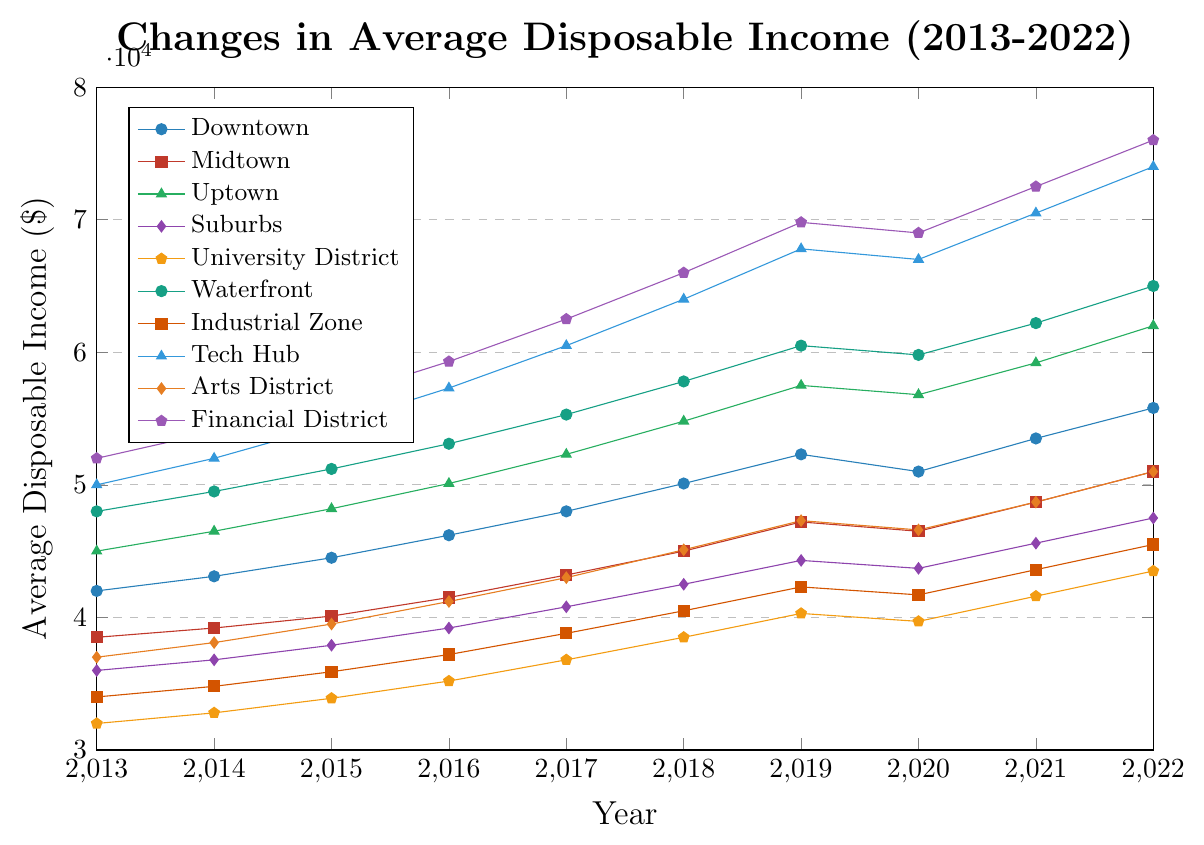What year did Downtown experience a decrease in average disposable income? Locate the data for Downtown and identify the year where the line dips. The average disposable income for Downtown decreases from 2019 to 2020, dipping from $52,300 to $51,000.
Answer: 2020 Which neighborhood had the highest disposable income in 2022? Locate the line for each neighborhood in the year 2022 and identify the highest value. The Financial District had the highest disposable income in 2022 with $76,000.
Answer: Financial District By how much did the disposable income in Tech Hub increase from 2013 to 2022? Identify the starting (2013) and ending (2022) values for Tech Hub and calculate the difference. The income increased from $50,000 in 2013 to $74,000 in 2022, resulting in an increase of $24,000.
Answer: $24,000 Which neighborhoods had disposable incomes greater than $50,000 in 2022? Review the 2022 disposable incomes for all neighborhoods and select those greater than $50,000. The neighborhoods are Downtown, Midtown, Uptown, Waterfront, Tech Hub, and Financial District.
Answer: Downtown, Midtown, Uptown, Waterfront, Tech Hub, Financial District Did the University District’s average disposable income ever exceed $40,000 before 2019? Check the disposable incomes for University District from 2013 to 2018. The income exceeds $40,000 in 2018 when it reaches $40,300.
Answer: Yes, in 2018 Compare the disposable incomes of Midtown and Arts District in 2017. Which one was higher? Locate the 2017 values for both Midtown and Arts District, then compare them. Midtown had a disposable income of $43,200, which is higher than Arts District's $43,000.
Answer: Midtown What is the combined disposable income for Suburbs and Industrial Zone in 2020? Identify the 2020 values for both neighborhoods and sum them. The income is $43,700 for Suburbs and $41,700 for Industrial Zone. The combined income is $43,700 + $41,700 = $85,400.
Answer: $85,400 Which neighborhood had the steepest rise in disposable income from 2018 to 2019? Calculate the income rise for each neighborhood between 2018 and 2019 and identify the steepest. Tech Hub had the steepest rise from $64,000 to $67,800, an increase of $3,800.
Answer: Tech Hub 